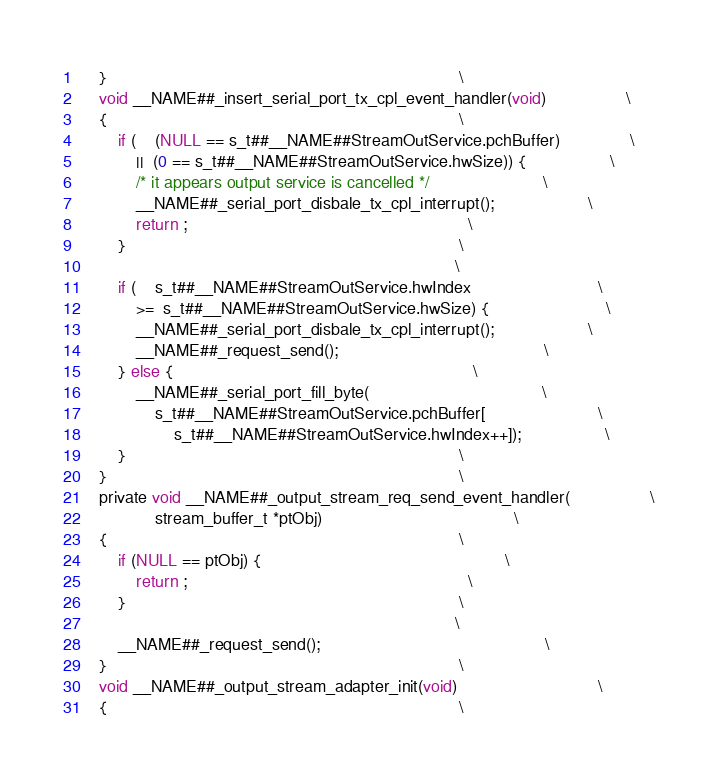Convert code to text. <code><loc_0><loc_0><loc_500><loc_500><_C_>    }                                                                           \
    void __NAME##_insert_serial_port_tx_cpl_event_handler(void)                 \
    {                                                                           \
        if (    (NULL == s_t##__NAME##StreamOutService.pchBuffer)               \
            ||  (0 == s_t##__NAME##StreamOutService.hwSize)) {                  \
            /* it appears output service is cancelled */                        \
            __NAME##_serial_port_disbale_tx_cpl_interrupt();                    \
            return ;                                                            \
        }                                                                       \
                                                                                \
        if (    s_t##__NAME##StreamOutService.hwIndex                           \
            >=  s_t##__NAME##StreamOutService.hwSize) {                         \
            __NAME##_serial_port_disbale_tx_cpl_interrupt();                    \
            __NAME##_request_send();                                            \
        } else {                                                                \
            __NAME##_serial_port_fill_byte(                                     \
                s_t##__NAME##StreamOutService.pchBuffer[                        \
                    s_t##__NAME##StreamOutService.hwIndex++]);                  \
        }                                                                       \
    }                                                                           \
    private void __NAME##_output_stream_req_send_event_handler(                 \
                stream_buffer_t *ptObj)                                         \
    {                                                                           \
        if (NULL == ptObj) {                                                    \
            return ;                                                            \
        }                                                                       \
                                                                                \
        __NAME##_request_send();                                                \
    }                                                                           \
    void __NAME##_output_stream_adapter_init(void)                              \
    {                                                                           \</code> 